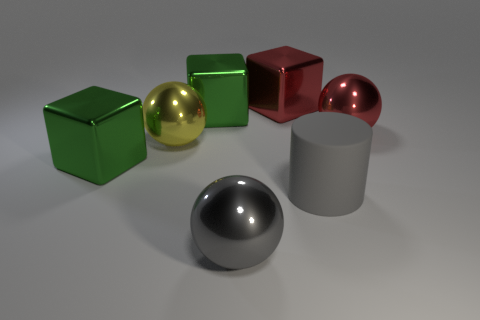Is the number of big cubes that are left of the yellow object less than the number of rubber cylinders that are right of the red ball?
Provide a short and direct response. No. What number of green blocks are the same size as the red block?
Provide a succinct answer. 2. Does the sphere that is to the left of the large gray metallic object have the same material as the large red sphere?
Ensure brevity in your answer.  Yes. Are there any red blocks?
Your answer should be very brief. Yes. What is the size of the gray sphere that is the same material as the red cube?
Offer a terse response. Large. Is there a big metal sphere of the same color as the matte cylinder?
Keep it short and to the point. Yes. Do the matte cylinder in front of the yellow shiny sphere and the shiny object that is in front of the big matte cylinder have the same color?
Provide a succinct answer. Yes. The metal object that is the same color as the large cylinder is what size?
Your answer should be very brief. Large. Are there any tiny blue spheres made of the same material as the big cylinder?
Provide a short and direct response. No. The matte thing is what color?
Ensure brevity in your answer.  Gray. 